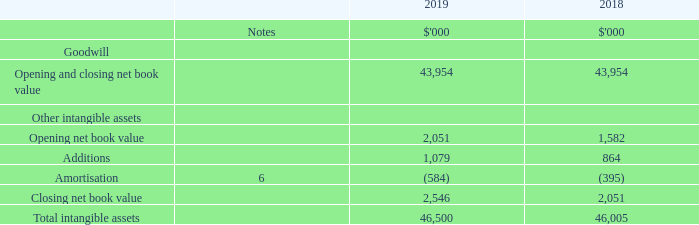10.5. Intangible assets
Impairment testing of goodwill
Goodwill has been allocated to the listed group (NSR). Management have determined that the listed group, which is considered one operating segment (see note 4), is the appropriate CGU against which to allocate these intangible assets owing to the synergies arising from combining the portfolios of the Group.
The recoverable amount of the listed group has been determined based on the fair value less costs of disposal method using the fair value quoted on an active market. As at 1 July 2019, NSR had 773,343,956 stapled securities quoted on the Australian Securities Exchange at $1.745 per security providing a market capitalisation of $1,349.5m.
This amount is in excess of the carrying amount of the Group’s net assets at 30 June 2019 which includes the contract for future issue of equity recognised as contributed equity within the statement of financial position at this date (see note 13). Had the security price decreased by 2.5% the market capitalisation would still have been in excess of the carrying amount.
What determines the recoverable amount of the listed group? Based on the fair value less costs of disposal method using the fair value quoted on an active market. How much did NSR had stapled securities quoted on the Australian Securities Exchange as at 1 July 2019? 773,343,956. What would be the impact if security price decreased by 2.5%? The market capitalisation would still have been in excess of the carrying amount. What is the change in Other intangible assets Opening net book value from 2018 to 2019?
Answer scale should be: thousand. 2,051-1,582
Answer: 469. What is the change in Other intangible assets Additions from 2018 to 2019?
Answer scale should be: thousand. 1,079-864
Answer: 215. What is the change in Other intangible assets Amortisation 2018 to 2019?
Answer scale should be: thousand. 584-395
Answer: 189. 